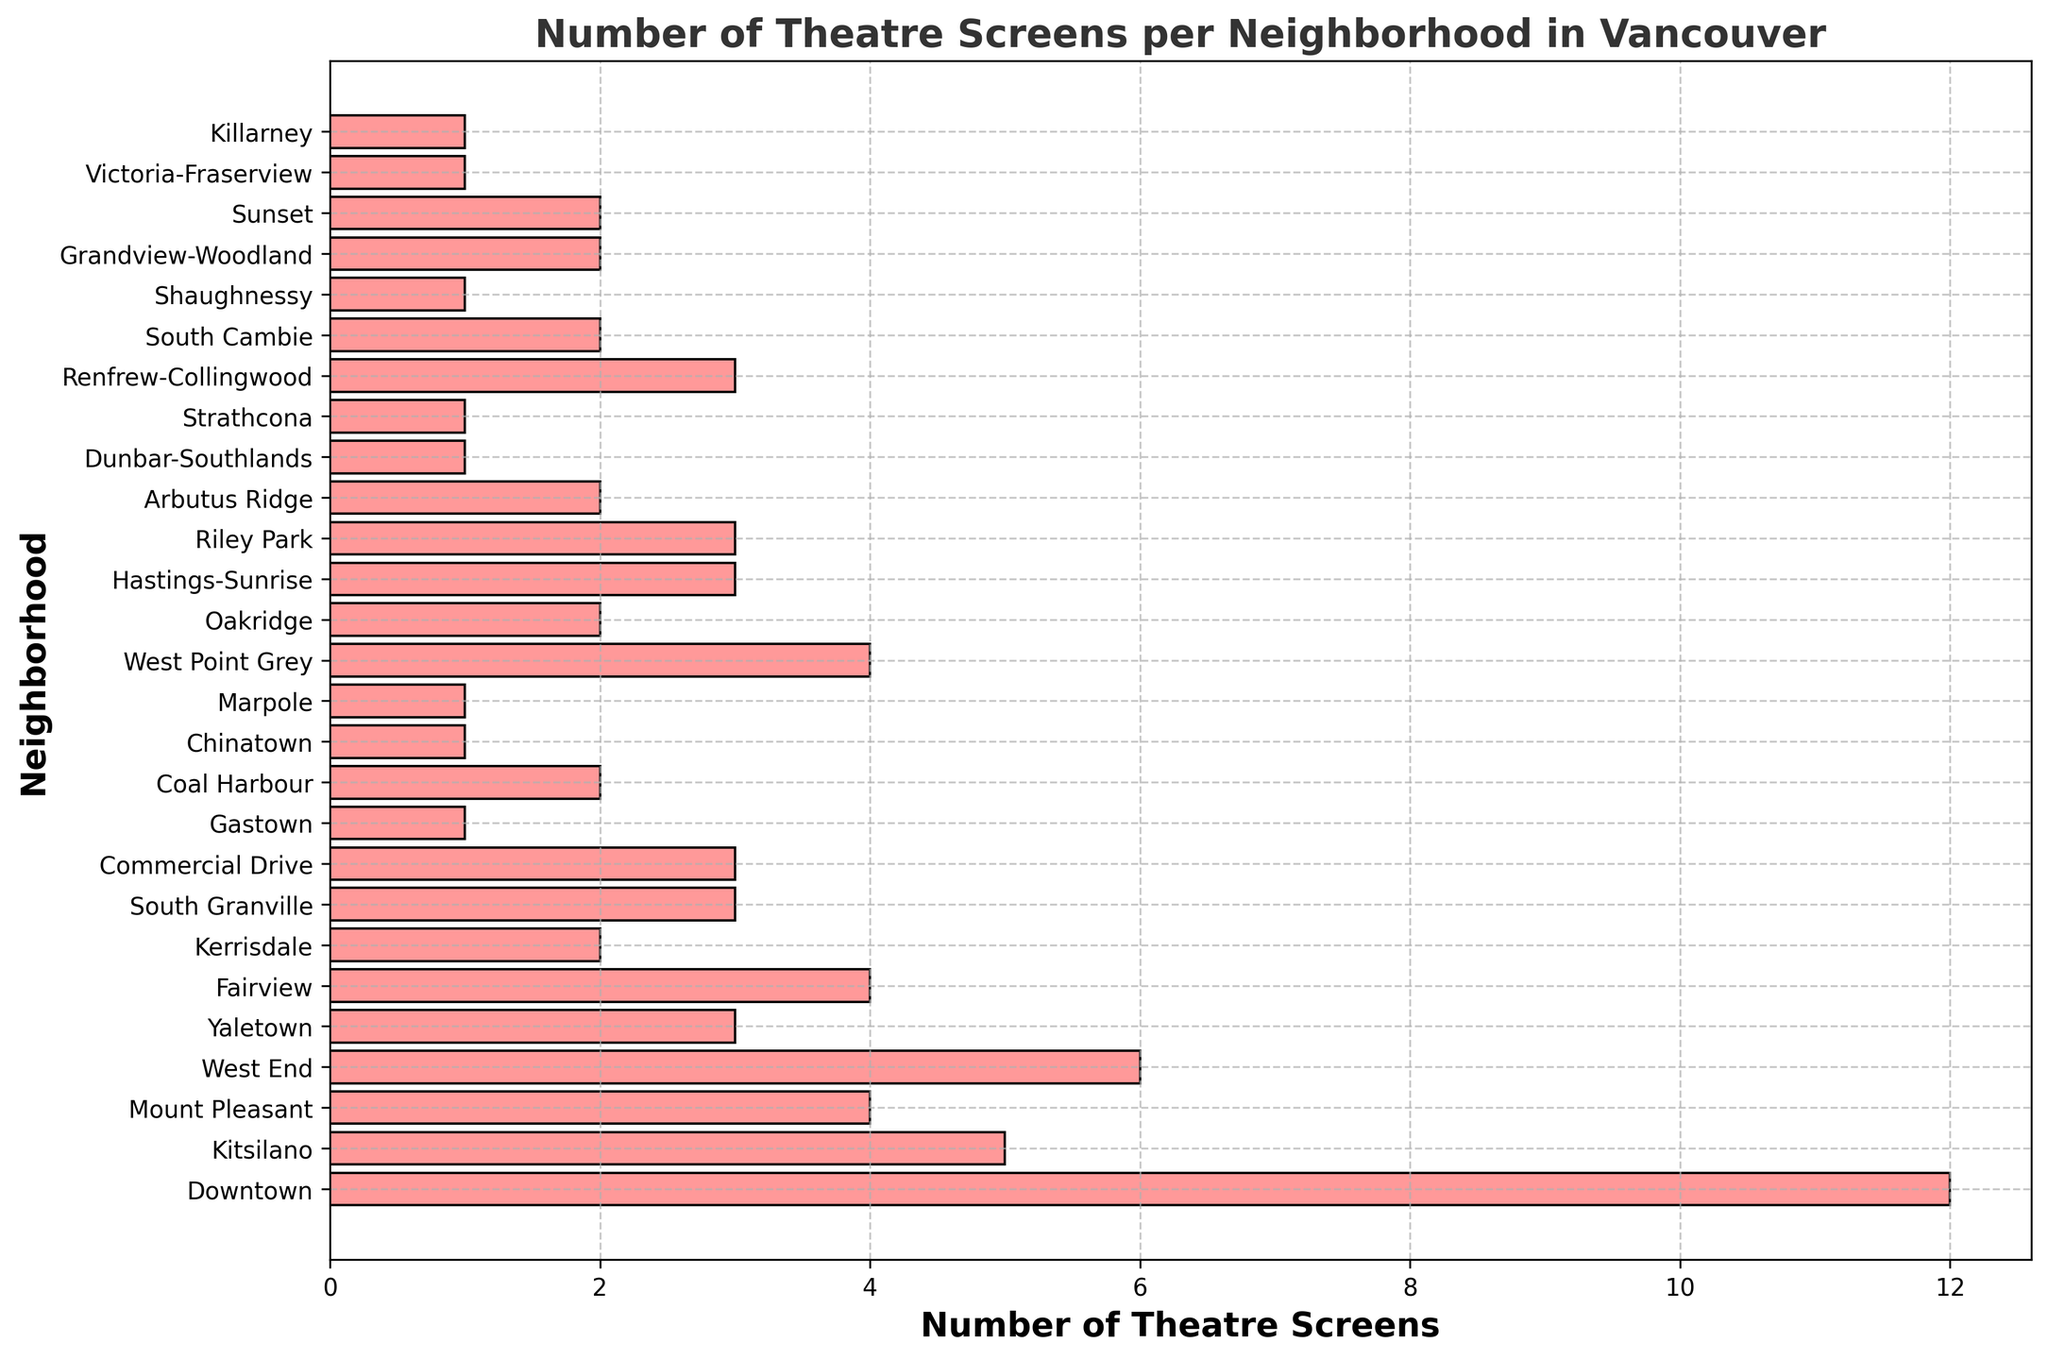Which neighborhood has the highest number of theatre screens? The neighborhood with the longest bar represents the highest number of theatre screens. Downtown has the longest bar with 12 theatre screens.
Answer: Downtown What is the total number of theatre screens in neighborhoods with more than 5 screens? Sum the theatre screens for neighborhoods with more than 5 screens: Downtown (12) and West End (6). The total is 12 + 6 = 18.
Answer: 18 Which neighborhood has more theatre screens, Kitsilano or Oakridge? Compare the lengths of the bars for Kitsilano and Oakridge. Kitsilano has 5 theatre screens, and Oakridge has 2.
Answer: Kitsilano How many neighborhoods have exactly 3 theatre screens? Count the bars that reach 3 on the x-axis: Yaletown, South Granville, Commercial Drive, Hastings-Sunrise, Riley Park, Renfrew-Collingwood. There are 6 such neighborhoods.
Answer: 6 What is the median number of theatre screens per neighborhood? Arrange the numbers of theatre screens in ascending order and find the middle value. The sorted list is: 1, 1, 1, 1, 1, 2, 2, 2, 2, 2, 2, 3, 3, 3, 3, 3, 3, 4, 4, 4, 4, 4, 5, 6, 12. The median value is the 14th number, which is 3.
Answer: 3 Which neighborhoods have fewer than 2 theatre screens? Identify the neighborhoods by observing the bars shorter than 2 units on the x-axis. These neighborhoods are Gastown, Chinatown, Marpole, Dunbar-Southlands, Strathcona, Victoria-Fraserview, and Killarney.
Answer: Gastown, Chinatown, Marpole, Dunbar-Southlands, Strathcona, Victoria-Fraserview, Killarney What is the average number of theatre screens per neighborhood? Sum all the theatre screens and divide by the number of neighborhoods: (12 + 5 + 4 + 6 + 3 + 4 + 2 + 3 + 3 + 1 + 2 + 1 + 1 + 4 + 2 + 3 + 3 + 2 + 1 + 1 + 3 + 2 + 1 + 2 + 2 + 1) / 27. The total is 69, so the average is 69/27 ≈ 2.56.
Answer: 2.56 